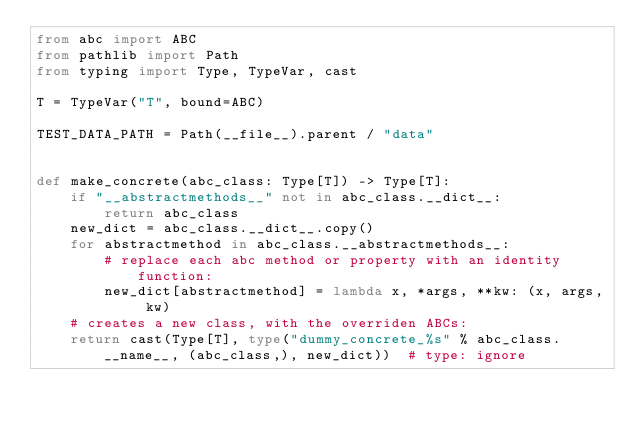<code> <loc_0><loc_0><loc_500><loc_500><_Python_>from abc import ABC
from pathlib import Path
from typing import Type, TypeVar, cast

T = TypeVar("T", bound=ABC)

TEST_DATA_PATH = Path(__file__).parent / "data"


def make_concrete(abc_class: Type[T]) -> Type[T]:
    if "__abstractmethods__" not in abc_class.__dict__:
        return abc_class
    new_dict = abc_class.__dict__.copy()
    for abstractmethod in abc_class.__abstractmethods__:
        # replace each abc method or property with an identity function:
        new_dict[abstractmethod] = lambda x, *args, **kw: (x, args, kw)
    # creates a new class, with the overriden ABCs:
    return cast(Type[T], type("dummy_concrete_%s" % abc_class.__name__, (abc_class,), new_dict))  # type: ignore
</code> 